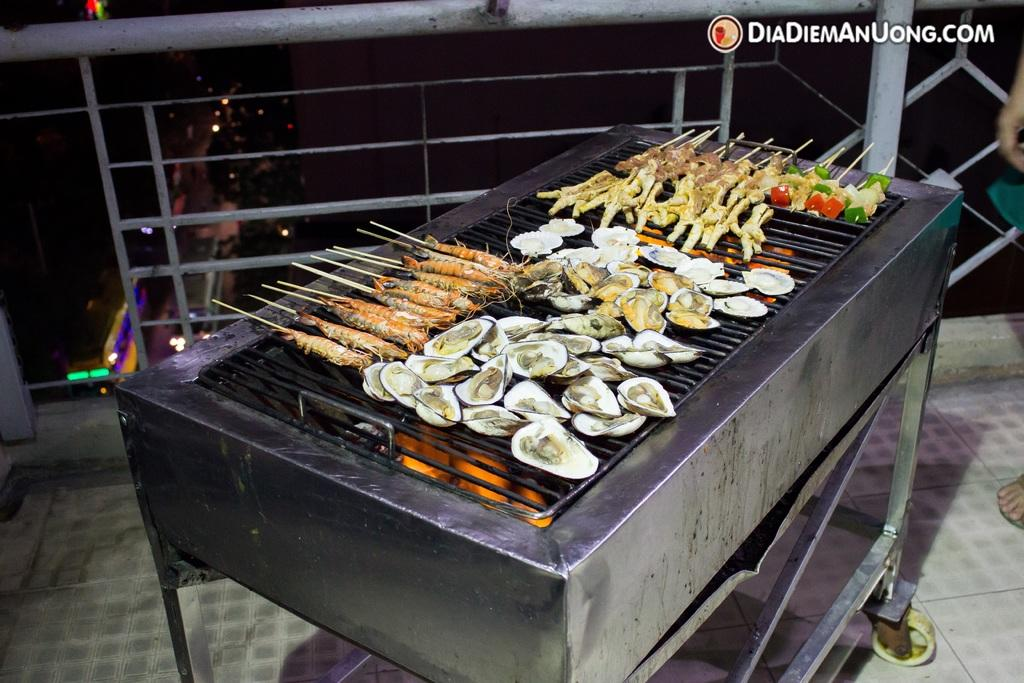Provide a one-sentence caption for the provided image. A grill set up on a balcony overlooking the city from DiaDiemAnUong.com. 